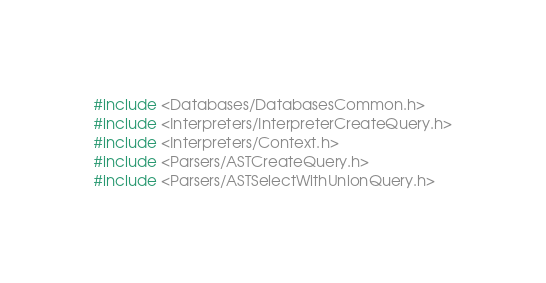Convert code to text. <code><loc_0><loc_0><loc_500><loc_500><_C++_>#include <Databases/DatabasesCommon.h>
#include <Interpreters/InterpreterCreateQuery.h>
#include <Interpreters/Context.h>
#include <Parsers/ASTCreateQuery.h>
#include <Parsers/ASTSelectWithUnionQuery.h></code> 